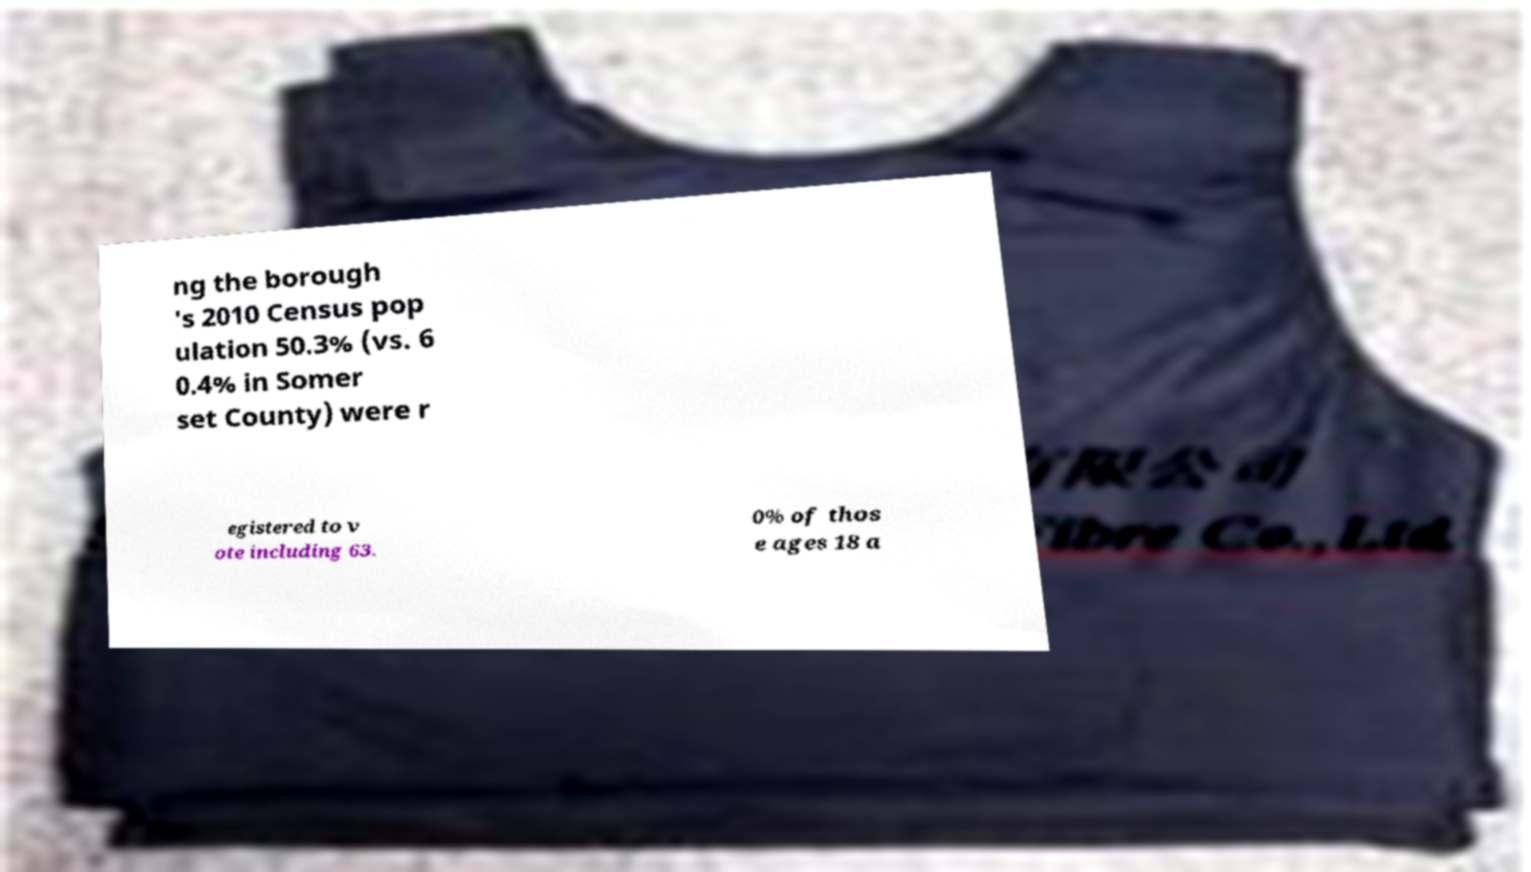Can you accurately transcribe the text from the provided image for me? ng the borough 's 2010 Census pop ulation 50.3% (vs. 6 0.4% in Somer set County) were r egistered to v ote including 63. 0% of thos e ages 18 a 